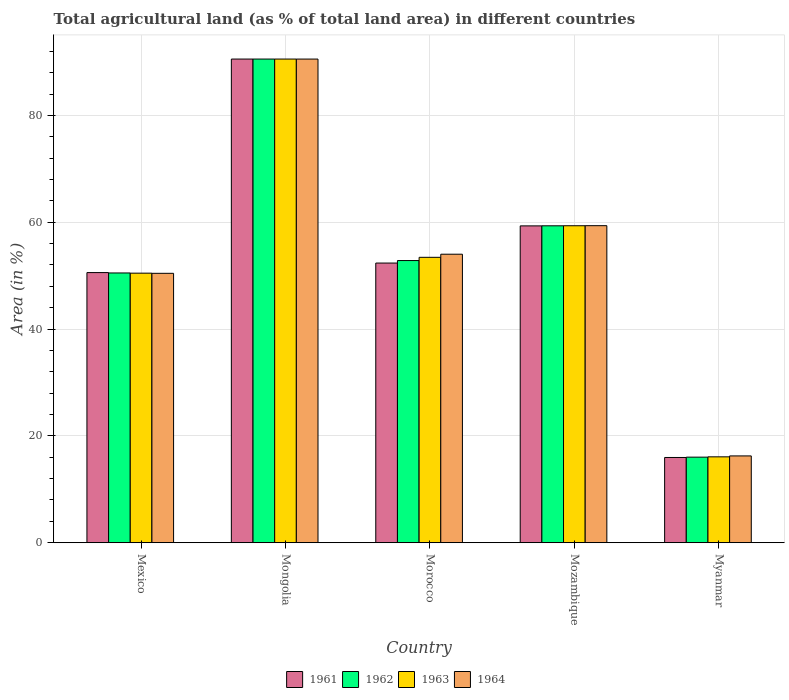How many different coloured bars are there?
Your answer should be very brief. 4. Are the number of bars per tick equal to the number of legend labels?
Make the answer very short. Yes. Are the number of bars on each tick of the X-axis equal?
Give a very brief answer. Yes. How many bars are there on the 4th tick from the right?
Offer a terse response. 4. What is the label of the 1st group of bars from the left?
Your answer should be very brief. Mexico. In how many cases, is the number of bars for a given country not equal to the number of legend labels?
Provide a succinct answer. 0. What is the percentage of agricultural land in 1963 in Morocco?
Offer a terse response. 53.43. Across all countries, what is the maximum percentage of agricultural land in 1964?
Make the answer very short. 90.55. Across all countries, what is the minimum percentage of agricultural land in 1964?
Make the answer very short. 16.25. In which country was the percentage of agricultural land in 1961 maximum?
Your response must be concise. Mongolia. In which country was the percentage of agricultural land in 1961 minimum?
Your response must be concise. Myanmar. What is the total percentage of agricultural land in 1963 in the graph?
Your answer should be compact. 269.88. What is the difference between the percentage of agricultural land in 1964 in Mozambique and that in Myanmar?
Give a very brief answer. 43.11. What is the difference between the percentage of agricultural land in 1961 in Myanmar and the percentage of agricultural land in 1964 in Mozambique?
Your answer should be compact. -43.4. What is the average percentage of agricultural land in 1963 per country?
Provide a succinct answer. 53.98. What is the difference between the percentage of agricultural land of/in 1963 and percentage of agricultural land of/in 1961 in Morocco?
Give a very brief answer. 1.08. What is the ratio of the percentage of agricultural land in 1961 in Morocco to that in Mozambique?
Offer a very short reply. 0.88. Is the percentage of agricultural land in 1962 in Mozambique less than that in Myanmar?
Provide a short and direct response. No. What is the difference between the highest and the second highest percentage of agricultural land in 1962?
Make the answer very short. 31.22. What is the difference between the highest and the lowest percentage of agricultural land in 1962?
Your response must be concise. 74.53. Is the sum of the percentage of agricultural land in 1963 in Mexico and Mongolia greater than the maximum percentage of agricultural land in 1962 across all countries?
Your answer should be compact. Yes. Is it the case that in every country, the sum of the percentage of agricultural land in 1963 and percentage of agricultural land in 1961 is greater than the sum of percentage of agricultural land in 1964 and percentage of agricultural land in 1962?
Your answer should be compact. No. What does the 1st bar from the right in Mongolia represents?
Keep it short and to the point. 1964. How many bars are there?
Keep it short and to the point. 20. Does the graph contain any zero values?
Your answer should be very brief. No. Where does the legend appear in the graph?
Provide a short and direct response. Bottom center. How are the legend labels stacked?
Offer a terse response. Horizontal. What is the title of the graph?
Provide a succinct answer. Total agricultural land (as % of total land area) in different countries. What is the label or title of the Y-axis?
Provide a succinct answer. Area (in %). What is the Area (in %) of 1961 in Mexico?
Make the answer very short. 50.58. What is the Area (in %) in 1962 in Mexico?
Provide a short and direct response. 50.5. What is the Area (in %) in 1963 in Mexico?
Your answer should be very brief. 50.47. What is the Area (in %) in 1964 in Mexico?
Provide a short and direct response. 50.44. What is the Area (in %) of 1961 in Mongolia?
Provide a succinct answer. 90.56. What is the Area (in %) in 1962 in Mongolia?
Provide a succinct answer. 90.56. What is the Area (in %) of 1963 in Mongolia?
Offer a terse response. 90.56. What is the Area (in %) in 1964 in Mongolia?
Provide a succinct answer. 90.55. What is the Area (in %) of 1961 in Morocco?
Offer a very short reply. 52.36. What is the Area (in %) in 1962 in Morocco?
Offer a terse response. 52.83. What is the Area (in %) of 1963 in Morocco?
Ensure brevity in your answer.  53.43. What is the Area (in %) of 1964 in Morocco?
Your answer should be very brief. 54.02. What is the Area (in %) in 1961 in Mozambique?
Offer a very short reply. 59.32. What is the Area (in %) in 1962 in Mozambique?
Your response must be concise. 59.34. What is the Area (in %) of 1963 in Mozambique?
Offer a terse response. 59.35. What is the Area (in %) of 1964 in Mozambique?
Provide a short and direct response. 59.36. What is the Area (in %) of 1961 in Myanmar?
Provide a short and direct response. 15.96. What is the Area (in %) in 1962 in Myanmar?
Your answer should be compact. 16.02. What is the Area (in %) in 1963 in Myanmar?
Your answer should be very brief. 16.08. What is the Area (in %) of 1964 in Myanmar?
Ensure brevity in your answer.  16.25. Across all countries, what is the maximum Area (in %) in 1961?
Ensure brevity in your answer.  90.56. Across all countries, what is the maximum Area (in %) of 1962?
Offer a terse response. 90.56. Across all countries, what is the maximum Area (in %) of 1963?
Offer a very short reply. 90.56. Across all countries, what is the maximum Area (in %) of 1964?
Provide a succinct answer. 90.55. Across all countries, what is the minimum Area (in %) in 1961?
Your response must be concise. 15.96. Across all countries, what is the minimum Area (in %) in 1962?
Provide a short and direct response. 16.02. Across all countries, what is the minimum Area (in %) of 1963?
Provide a succinct answer. 16.08. Across all countries, what is the minimum Area (in %) of 1964?
Ensure brevity in your answer.  16.25. What is the total Area (in %) of 1961 in the graph?
Provide a succinct answer. 268.77. What is the total Area (in %) in 1962 in the graph?
Provide a short and direct response. 269.25. What is the total Area (in %) of 1963 in the graph?
Make the answer very short. 269.88. What is the total Area (in %) in 1964 in the graph?
Your answer should be very brief. 270.62. What is the difference between the Area (in %) of 1961 in Mexico and that in Mongolia?
Your response must be concise. -39.98. What is the difference between the Area (in %) in 1962 in Mexico and that in Mongolia?
Your answer should be very brief. -40.05. What is the difference between the Area (in %) in 1963 in Mexico and that in Mongolia?
Ensure brevity in your answer.  -40.09. What is the difference between the Area (in %) of 1964 in Mexico and that in Mongolia?
Provide a succinct answer. -40.12. What is the difference between the Area (in %) in 1961 in Mexico and that in Morocco?
Offer a very short reply. -1.78. What is the difference between the Area (in %) in 1962 in Mexico and that in Morocco?
Make the answer very short. -2.32. What is the difference between the Area (in %) of 1963 in Mexico and that in Morocco?
Make the answer very short. -2.97. What is the difference between the Area (in %) in 1964 in Mexico and that in Morocco?
Ensure brevity in your answer.  -3.58. What is the difference between the Area (in %) of 1961 in Mexico and that in Mozambique?
Ensure brevity in your answer.  -8.75. What is the difference between the Area (in %) of 1962 in Mexico and that in Mozambique?
Make the answer very short. -8.83. What is the difference between the Area (in %) in 1963 in Mexico and that in Mozambique?
Offer a very short reply. -8.88. What is the difference between the Area (in %) of 1964 in Mexico and that in Mozambique?
Make the answer very short. -8.92. What is the difference between the Area (in %) of 1961 in Mexico and that in Myanmar?
Ensure brevity in your answer.  34.62. What is the difference between the Area (in %) in 1962 in Mexico and that in Myanmar?
Your answer should be compact. 34.48. What is the difference between the Area (in %) in 1963 in Mexico and that in Myanmar?
Provide a succinct answer. 34.39. What is the difference between the Area (in %) of 1964 in Mexico and that in Myanmar?
Offer a terse response. 34.19. What is the difference between the Area (in %) in 1961 in Mongolia and that in Morocco?
Your response must be concise. 38.2. What is the difference between the Area (in %) in 1962 in Mongolia and that in Morocco?
Ensure brevity in your answer.  37.73. What is the difference between the Area (in %) in 1963 in Mongolia and that in Morocco?
Your response must be concise. 37.12. What is the difference between the Area (in %) in 1964 in Mongolia and that in Morocco?
Provide a succinct answer. 36.54. What is the difference between the Area (in %) in 1961 in Mongolia and that in Mozambique?
Ensure brevity in your answer.  31.23. What is the difference between the Area (in %) in 1962 in Mongolia and that in Mozambique?
Provide a short and direct response. 31.22. What is the difference between the Area (in %) in 1963 in Mongolia and that in Mozambique?
Your response must be concise. 31.21. What is the difference between the Area (in %) of 1964 in Mongolia and that in Mozambique?
Keep it short and to the point. 31.2. What is the difference between the Area (in %) of 1961 in Mongolia and that in Myanmar?
Give a very brief answer. 74.6. What is the difference between the Area (in %) in 1962 in Mongolia and that in Myanmar?
Make the answer very short. 74.53. What is the difference between the Area (in %) of 1963 in Mongolia and that in Myanmar?
Give a very brief answer. 74.48. What is the difference between the Area (in %) in 1964 in Mongolia and that in Myanmar?
Make the answer very short. 74.3. What is the difference between the Area (in %) in 1961 in Morocco and that in Mozambique?
Your answer should be compact. -6.96. What is the difference between the Area (in %) of 1962 in Morocco and that in Mozambique?
Make the answer very short. -6.51. What is the difference between the Area (in %) in 1963 in Morocco and that in Mozambique?
Offer a very short reply. -5.91. What is the difference between the Area (in %) in 1964 in Morocco and that in Mozambique?
Provide a short and direct response. -5.34. What is the difference between the Area (in %) of 1961 in Morocco and that in Myanmar?
Make the answer very short. 36.4. What is the difference between the Area (in %) of 1962 in Morocco and that in Myanmar?
Provide a succinct answer. 36.81. What is the difference between the Area (in %) of 1963 in Morocco and that in Myanmar?
Your response must be concise. 37.36. What is the difference between the Area (in %) of 1964 in Morocco and that in Myanmar?
Provide a short and direct response. 37.77. What is the difference between the Area (in %) in 1961 in Mozambique and that in Myanmar?
Offer a very short reply. 43.36. What is the difference between the Area (in %) of 1962 in Mozambique and that in Myanmar?
Keep it short and to the point. 43.31. What is the difference between the Area (in %) of 1963 in Mozambique and that in Myanmar?
Your answer should be compact. 43.27. What is the difference between the Area (in %) of 1964 in Mozambique and that in Myanmar?
Ensure brevity in your answer.  43.11. What is the difference between the Area (in %) in 1961 in Mexico and the Area (in %) in 1962 in Mongolia?
Keep it short and to the point. -39.98. What is the difference between the Area (in %) in 1961 in Mexico and the Area (in %) in 1963 in Mongolia?
Provide a succinct answer. -39.98. What is the difference between the Area (in %) in 1961 in Mexico and the Area (in %) in 1964 in Mongolia?
Offer a terse response. -39.98. What is the difference between the Area (in %) in 1962 in Mexico and the Area (in %) in 1963 in Mongolia?
Your answer should be very brief. -40.05. What is the difference between the Area (in %) of 1962 in Mexico and the Area (in %) of 1964 in Mongolia?
Offer a terse response. -40.05. What is the difference between the Area (in %) of 1963 in Mexico and the Area (in %) of 1964 in Mongolia?
Offer a terse response. -40.09. What is the difference between the Area (in %) of 1961 in Mexico and the Area (in %) of 1962 in Morocco?
Your answer should be compact. -2.25. What is the difference between the Area (in %) of 1961 in Mexico and the Area (in %) of 1963 in Morocco?
Your answer should be compact. -2.86. What is the difference between the Area (in %) of 1961 in Mexico and the Area (in %) of 1964 in Morocco?
Your response must be concise. -3.44. What is the difference between the Area (in %) of 1962 in Mexico and the Area (in %) of 1963 in Morocco?
Provide a succinct answer. -2.93. What is the difference between the Area (in %) in 1962 in Mexico and the Area (in %) in 1964 in Morocco?
Make the answer very short. -3.51. What is the difference between the Area (in %) of 1963 in Mexico and the Area (in %) of 1964 in Morocco?
Your answer should be very brief. -3.55. What is the difference between the Area (in %) of 1961 in Mexico and the Area (in %) of 1962 in Mozambique?
Your response must be concise. -8.76. What is the difference between the Area (in %) of 1961 in Mexico and the Area (in %) of 1963 in Mozambique?
Give a very brief answer. -8.77. What is the difference between the Area (in %) in 1961 in Mexico and the Area (in %) in 1964 in Mozambique?
Give a very brief answer. -8.78. What is the difference between the Area (in %) in 1962 in Mexico and the Area (in %) in 1963 in Mozambique?
Give a very brief answer. -8.84. What is the difference between the Area (in %) in 1962 in Mexico and the Area (in %) in 1964 in Mozambique?
Offer a very short reply. -8.85. What is the difference between the Area (in %) in 1963 in Mexico and the Area (in %) in 1964 in Mozambique?
Offer a very short reply. -8.89. What is the difference between the Area (in %) of 1961 in Mexico and the Area (in %) of 1962 in Myanmar?
Your response must be concise. 34.55. What is the difference between the Area (in %) in 1961 in Mexico and the Area (in %) in 1963 in Myanmar?
Your answer should be compact. 34.5. What is the difference between the Area (in %) in 1961 in Mexico and the Area (in %) in 1964 in Myanmar?
Provide a succinct answer. 34.33. What is the difference between the Area (in %) of 1962 in Mexico and the Area (in %) of 1963 in Myanmar?
Offer a terse response. 34.43. What is the difference between the Area (in %) in 1962 in Mexico and the Area (in %) in 1964 in Myanmar?
Ensure brevity in your answer.  34.25. What is the difference between the Area (in %) in 1963 in Mexico and the Area (in %) in 1964 in Myanmar?
Ensure brevity in your answer.  34.22. What is the difference between the Area (in %) of 1961 in Mongolia and the Area (in %) of 1962 in Morocco?
Make the answer very short. 37.73. What is the difference between the Area (in %) in 1961 in Mongolia and the Area (in %) in 1963 in Morocco?
Your answer should be very brief. 37.12. What is the difference between the Area (in %) in 1961 in Mongolia and the Area (in %) in 1964 in Morocco?
Provide a succinct answer. 36.54. What is the difference between the Area (in %) of 1962 in Mongolia and the Area (in %) of 1963 in Morocco?
Offer a very short reply. 37.12. What is the difference between the Area (in %) of 1962 in Mongolia and the Area (in %) of 1964 in Morocco?
Your response must be concise. 36.54. What is the difference between the Area (in %) in 1963 in Mongolia and the Area (in %) in 1964 in Morocco?
Keep it short and to the point. 36.54. What is the difference between the Area (in %) in 1961 in Mongolia and the Area (in %) in 1962 in Mozambique?
Provide a short and direct response. 31.22. What is the difference between the Area (in %) of 1961 in Mongolia and the Area (in %) of 1963 in Mozambique?
Keep it short and to the point. 31.21. What is the difference between the Area (in %) of 1961 in Mongolia and the Area (in %) of 1964 in Mozambique?
Your response must be concise. 31.2. What is the difference between the Area (in %) of 1962 in Mongolia and the Area (in %) of 1963 in Mozambique?
Offer a terse response. 31.21. What is the difference between the Area (in %) of 1962 in Mongolia and the Area (in %) of 1964 in Mozambique?
Your answer should be very brief. 31.2. What is the difference between the Area (in %) in 1963 in Mongolia and the Area (in %) in 1964 in Mozambique?
Give a very brief answer. 31.2. What is the difference between the Area (in %) of 1961 in Mongolia and the Area (in %) of 1962 in Myanmar?
Offer a very short reply. 74.53. What is the difference between the Area (in %) of 1961 in Mongolia and the Area (in %) of 1963 in Myanmar?
Your answer should be compact. 74.48. What is the difference between the Area (in %) in 1961 in Mongolia and the Area (in %) in 1964 in Myanmar?
Your answer should be very brief. 74.31. What is the difference between the Area (in %) in 1962 in Mongolia and the Area (in %) in 1963 in Myanmar?
Offer a very short reply. 74.48. What is the difference between the Area (in %) in 1962 in Mongolia and the Area (in %) in 1964 in Myanmar?
Your response must be concise. 74.31. What is the difference between the Area (in %) in 1963 in Mongolia and the Area (in %) in 1964 in Myanmar?
Offer a terse response. 74.31. What is the difference between the Area (in %) in 1961 in Morocco and the Area (in %) in 1962 in Mozambique?
Provide a succinct answer. -6.98. What is the difference between the Area (in %) in 1961 in Morocco and the Area (in %) in 1963 in Mozambique?
Provide a short and direct response. -6.99. What is the difference between the Area (in %) in 1961 in Morocco and the Area (in %) in 1964 in Mozambique?
Keep it short and to the point. -7. What is the difference between the Area (in %) of 1962 in Morocco and the Area (in %) of 1963 in Mozambique?
Provide a short and direct response. -6.52. What is the difference between the Area (in %) in 1962 in Morocco and the Area (in %) in 1964 in Mozambique?
Provide a succinct answer. -6.53. What is the difference between the Area (in %) of 1963 in Morocco and the Area (in %) of 1964 in Mozambique?
Offer a terse response. -5.92. What is the difference between the Area (in %) of 1961 in Morocco and the Area (in %) of 1962 in Myanmar?
Offer a very short reply. 36.34. What is the difference between the Area (in %) in 1961 in Morocco and the Area (in %) in 1963 in Myanmar?
Offer a very short reply. 36.28. What is the difference between the Area (in %) of 1961 in Morocco and the Area (in %) of 1964 in Myanmar?
Make the answer very short. 36.11. What is the difference between the Area (in %) of 1962 in Morocco and the Area (in %) of 1963 in Myanmar?
Offer a terse response. 36.75. What is the difference between the Area (in %) in 1962 in Morocco and the Area (in %) in 1964 in Myanmar?
Make the answer very short. 36.58. What is the difference between the Area (in %) of 1963 in Morocco and the Area (in %) of 1964 in Myanmar?
Give a very brief answer. 37.18. What is the difference between the Area (in %) of 1961 in Mozambique and the Area (in %) of 1962 in Myanmar?
Provide a succinct answer. 43.3. What is the difference between the Area (in %) in 1961 in Mozambique and the Area (in %) in 1963 in Myanmar?
Your answer should be compact. 43.24. What is the difference between the Area (in %) in 1961 in Mozambique and the Area (in %) in 1964 in Myanmar?
Your answer should be very brief. 43.07. What is the difference between the Area (in %) in 1962 in Mozambique and the Area (in %) in 1963 in Myanmar?
Give a very brief answer. 43.26. What is the difference between the Area (in %) in 1962 in Mozambique and the Area (in %) in 1964 in Myanmar?
Give a very brief answer. 43.09. What is the difference between the Area (in %) in 1963 in Mozambique and the Area (in %) in 1964 in Myanmar?
Make the answer very short. 43.1. What is the average Area (in %) of 1961 per country?
Make the answer very short. 53.75. What is the average Area (in %) in 1962 per country?
Your answer should be very brief. 53.85. What is the average Area (in %) in 1963 per country?
Your answer should be very brief. 53.98. What is the average Area (in %) in 1964 per country?
Your answer should be compact. 54.12. What is the difference between the Area (in %) in 1961 and Area (in %) in 1962 in Mexico?
Make the answer very short. 0.07. What is the difference between the Area (in %) in 1961 and Area (in %) in 1963 in Mexico?
Offer a very short reply. 0.11. What is the difference between the Area (in %) in 1961 and Area (in %) in 1964 in Mexico?
Your answer should be compact. 0.14. What is the difference between the Area (in %) in 1962 and Area (in %) in 1963 in Mexico?
Your answer should be very brief. 0.04. What is the difference between the Area (in %) in 1962 and Area (in %) in 1964 in Mexico?
Keep it short and to the point. 0.07. What is the difference between the Area (in %) in 1963 and Area (in %) in 1964 in Mexico?
Your response must be concise. 0.03. What is the difference between the Area (in %) of 1961 and Area (in %) of 1964 in Mongolia?
Your answer should be very brief. 0. What is the difference between the Area (in %) in 1962 and Area (in %) in 1964 in Mongolia?
Your response must be concise. 0. What is the difference between the Area (in %) in 1963 and Area (in %) in 1964 in Mongolia?
Keep it short and to the point. 0. What is the difference between the Area (in %) in 1961 and Area (in %) in 1962 in Morocco?
Ensure brevity in your answer.  -0.47. What is the difference between the Area (in %) of 1961 and Area (in %) of 1963 in Morocco?
Keep it short and to the point. -1.08. What is the difference between the Area (in %) in 1961 and Area (in %) in 1964 in Morocco?
Your answer should be compact. -1.66. What is the difference between the Area (in %) of 1962 and Area (in %) of 1963 in Morocco?
Your answer should be compact. -0.6. What is the difference between the Area (in %) of 1962 and Area (in %) of 1964 in Morocco?
Give a very brief answer. -1.19. What is the difference between the Area (in %) of 1963 and Area (in %) of 1964 in Morocco?
Give a very brief answer. -0.58. What is the difference between the Area (in %) of 1961 and Area (in %) of 1962 in Mozambique?
Your response must be concise. -0.01. What is the difference between the Area (in %) of 1961 and Area (in %) of 1963 in Mozambique?
Make the answer very short. -0.03. What is the difference between the Area (in %) of 1961 and Area (in %) of 1964 in Mozambique?
Provide a succinct answer. -0.04. What is the difference between the Area (in %) in 1962 and Area (in %) in 1963 in Mozambique?
Provide a succinct answer. -0.01. What is the difference between the Area (in %) in 1962 and Area (in %) in 1964 in Mozambique?
Your answer should be very brief. -0.02. What is the difference between the Area (in %) of 1963 and Area (in %) of 1964 in Mozambique?
Provide a succinct answer. -0.01. What is the difference between the Area (in %) in 1961 and Area (in %) in 1962 in Myanmar?
Your response must be concise. -0.06. What is the difference between the Area (in %) of 1961 and Area (in %) of 1963 in Myanmar?
Offer a very short reply. -0.12. What is the difference between the Area (in %) in 1961 and Area (in %) in 1964 in Myanmar?
Provide a succinct answer. -0.29. What is the difference between the Area (in %) of 1962 and Area (in %) of 1963 in Myanmar?
Ensure brevity in your answer.  -0.06. What is the difference between the Area (in %) of 1962 and Area (in %) of 1964 in Myanmar?
Your answer should be compact. -0.23. What is the difference between the Area (in %) of 1963 and Area (in %) of 1964 in Myanmar?
Provide a succinct answer. -0.17. What is the ratio of the Area (in %) in 1961 in Mexico to that in Mongolia?
Offer a terse response. 0.56. What is the ratio of the Area (in %) in 1962 in Mexico to that in Mongolia?
Offer a very short reply. 0.56. What is the ratio of the Area (in %) of 1963 in Mexico to that in Mongolia?
Keep it short and to the point. 0.56. What is the ratio of the Area (in %) of 1964 in Mexico to that in Mongolia?
Make the answer very short. 0.56. What is the ratio of the Area (in %) in 1961 in Mexico to that in Morocco?
Provide a short and direct response. 0.97. What is the ratio of the Area (in %) of 1962 in Mexico to that in Morocco?
Offer a terse response. 0.96. What is the ratio of the Area (in %) of 1963 in Mexico to that in Morocco?
Provide a succinct answer. 0.94. What is the ratio of the Area (in %) of 1964 in Mexico to that in Morocco?
Your answer should be very brief. 0.93. What is the ratio of the Area (in %) of 1961 in Mexico to that in Mozambique?
Make the answer very short. 0.85. What is the ratio of the Area (in %) of 1962 in Mexico to that in Mozambique?
Ensure brevity in your answer.  0.85. What is the ratio of the Area (in %) in 1963 in Mexico to that in Mozambique?
Offer a very short reply. 0.85. What is the ratio of the Area (in %) in 1964 in Mexico to that in Mozambique?
Offer a terse response. 0.85. What is the ratio of the Area (in %) of 1961 in Mexico to that in Myanmar?
Give a very brief answer. 3.17. What is the ratio of the Area (in %) in 1962 in Mexico to that in Myanmar?
Your answer should be very brief. 3.15. What is the ratio of the Area (in %) of 1963 in Mexico to that in Myanmar?
Make the answer very short. 3.14. What is the ratio of the Area (in %) of 1964 in Mexico to that in Myanmar?
Keep it short and to the point. 3.1. What is the ratio of the Area (in %) in 1961 in Mongolia to that in Morocco?
Offer a terse response. 1.73. What is the ratio of the Area (in %) in 1962 in Mongolia to that in Morocco?
Your response must be concise. 1.71. What is the ratio of the Area (in %) of 1963 in Mongolia to that in Morocco?
Provide a succinct answer. 1.69. What is the ratio of the Area (in %) of 1964 in Mongolia to that in Morocco?
Give a very brief answer. 1.68. What is the ratio of the Area (in %) of 1961 in Mongolia to that in Mozambique?
Make the answer very short. 1.53. What is the ratio of the Area (in %) in 1962 in Mongolia to that in Mozambique?
Your answer should be very brief. 1.53. What is the ratio of the Area (in %) in 1963 in Mongolia to that in Mozambique?
Keep it short and to the point. 1.53. What is the ratio of the Area (in %) of 1964 in Mongolia to that in Mozambique?
Offer a terse response. 1.53. What is the ratio of the Area (in %) of 1961 in Mongolia to that in Myanmar?
Offer a terse response. 5.67. What is the ratio of the Area (in %) in 1962 in Mongolia to that in Myanmar?
Ensure brevity in your answer.  5.65. What is the ratio of the Area (in %) of 1963 in Mongolia to that in Myanmar?
Your answer should be very brief. 5.63. What is the ratio of the Area (in %) of 1964 in Mongolia to that in Myanmar?
Ensure brevity in your answer.  5.57. What is the ratio of the Area (in %) in 1961 in Morocco to that in Mozambique?
Provide a succinct answer. 0.88. What is the ratio of the Area (in %) of 1962 in Morocco to that in Mozambique?
Provide a short and direct response. 0.89. What is the ratio of the Area (in %) of 1963 in Morocco to that in Mozambique?
Offer a very short reply. 0.9. What is the ratio of the Area (in %) of 1964 in Morocco to that in Mozambique?
Your response must be concise. 0.91. What is the ratio of the Area (in %) of 1961 in Morocco to that in Myanmar?
Provide a short and direct response. 3.28. What is the ratio of the Area (in %) in 1962 in Morocco to that in Myanmar?
Your answer should be very brief. 3.3. What is the ratio of the Area (in %) in 1963 in Morocco to that in Myanmar?
Provide a short and direct response. 3.32. What is the ratio of the Area (in %) of 1964 in Morocco to that in Myanmar?
Provide a succinct answer. 3.32. What is the ratio of the Area (in %) of 1961 in Mozambique to that in Myanmar?
Provide a succinct answer. 3.72. What is the ratio of the Area (in %) in 1962 in Mozambique to that in Myanmar?
Your answer should be compact. 3.7. What is the ratio of the Area (in %) in 1963 in Mozambique to that in Myanmar?
Keep it short and to the point. 3.69. What is the ratio of the Area (in %) in 1964 in Mozambique to that in Myanmar?
Provide a short and direct response. 3.65. What is the difference between the highest and the second highest Area (in %) in 1961?
Your answer should be compact. 31.23. What is the difference between the highest and the second highest Area (in %) of 1962?
Make the answer very short. 31.22. What is the difference between the highest and the second highest Area (in %) of 1963?
Ensure brevity in your answer.  31.21. What is the difference between the highest and the second highest Area (in %) of 1964?
Ensure brevity in your answer.  31.2. What is the difference between the highest and the lowest Area (in %) of 1961?
Keep it short and to the point. 74.6. What is the difference between the highest and the lowest Area (in %) in 1962?
Give a very brief answer. 74.53. What is the difference between the highest and the lowest Area (in %) of 1963?
Ensure brevity in your answer.  74.48. What is the difference between the highest and the lowest Area (in %) in 1964?
Provide a short and direct response. 74.3. 